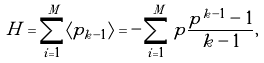Convert formula to latex. <formula><loc_0><loc_0><loc_500><loc_500>H = \sum ^ { M } _ { i = 1 } \langle p _ { k - 1 } \rangle = - \sum ^ { M } _ { i = 1 } p \frac { p ^ { k - 1 } - 1 } { k - 1 } ,</formula> 